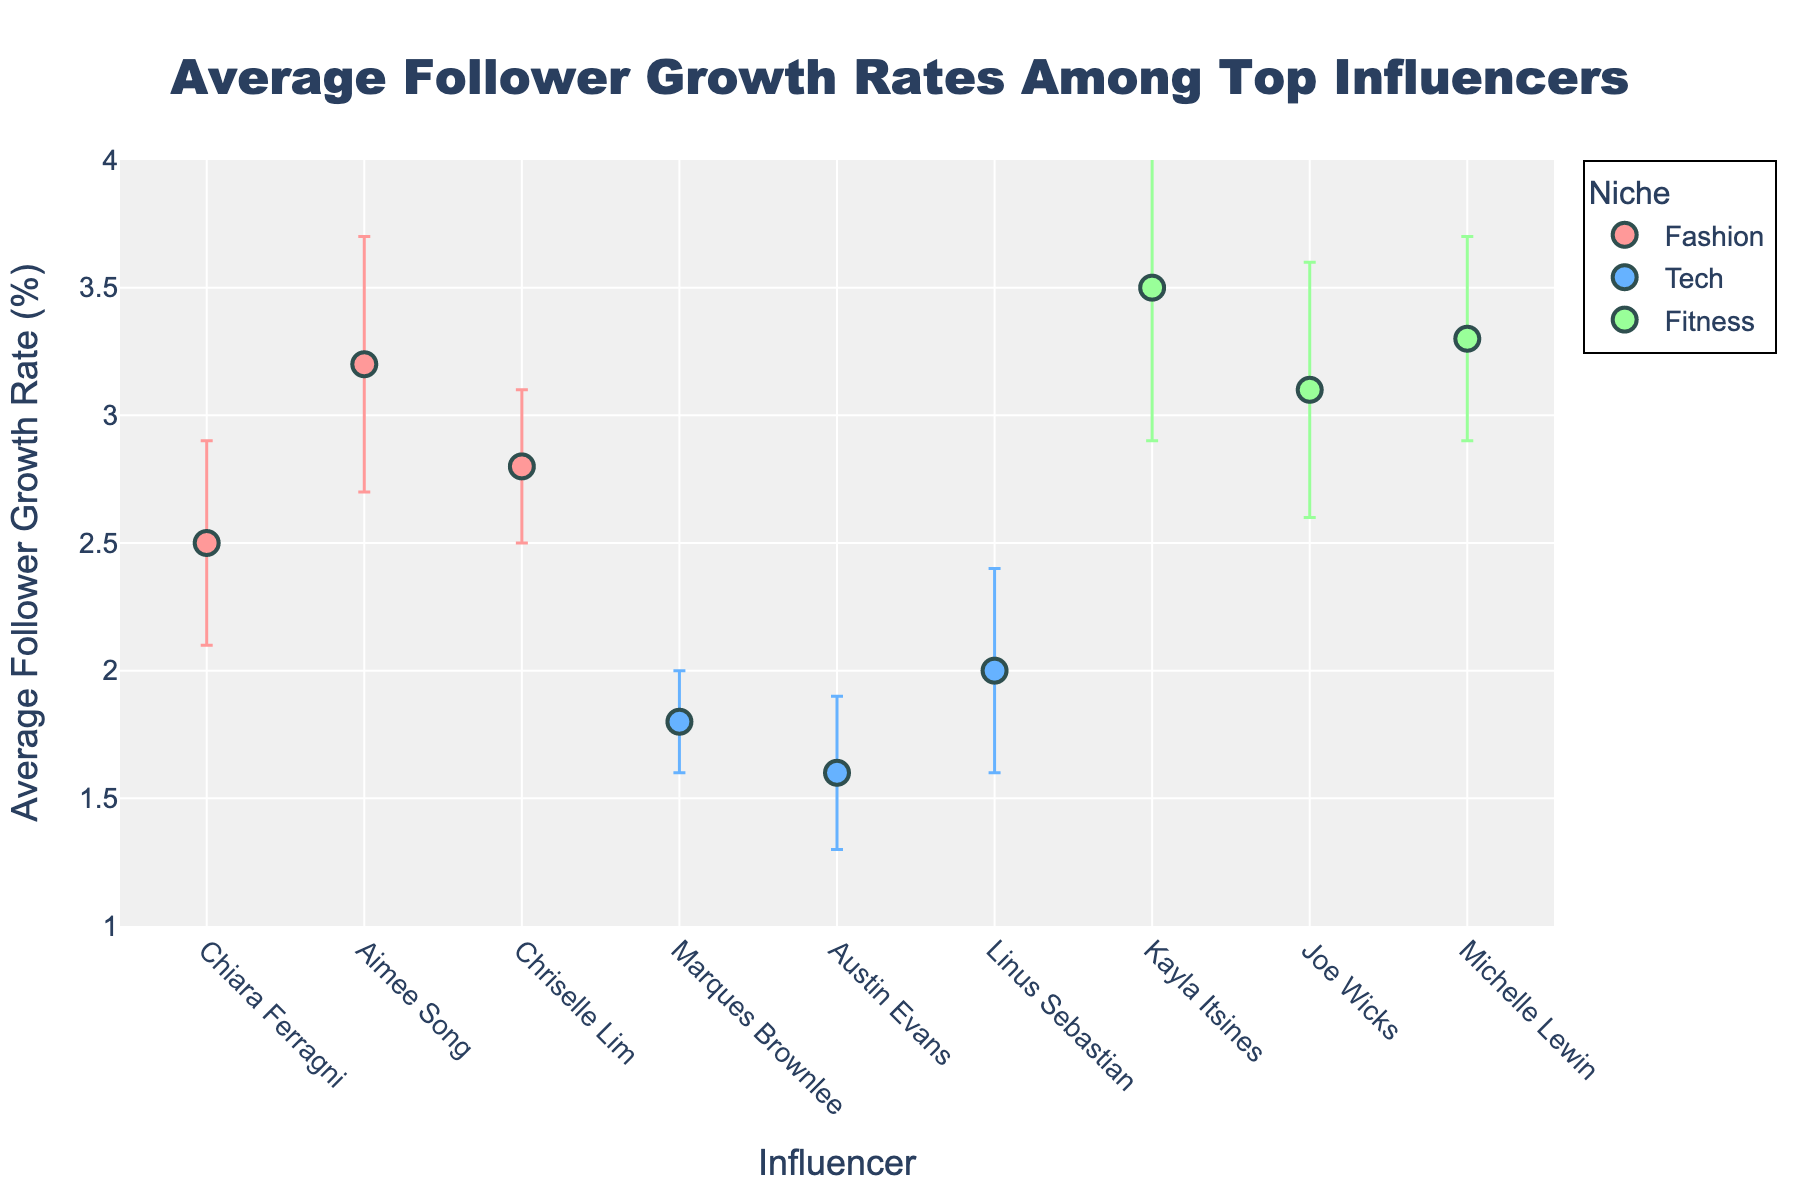What's the title of the plot? The title is typically located at the top of the plot. In this figure, it is "Average Follower Growth Rates Among Top Influencers".
Answer: Average Follower Growth Rates Among Top Influencers What is the y-axis measurement? The y-axis title is "Average Follower Growth Rate (%)", indicating that it measures the average follower growth rate in percentage.
Answer: Average Follower Growth Rate (%) How many influencers are represented in the fashion niche? By inspecting the x-axis labels under the 'Fashion' category and counting the data points (dots) within that niche, there are three influencers: Chiara Ferragni, Aimee Song, and Chriselle Lim.
Answer: 3 Which influencer in the tech niche has the highest average follower growth rate? By looking at the y-axis values of the dots representing tech influencers, Linus Sebastian has the highest at 2.0%.
Answer: Linus Sebastian Among the fitness influencers, who has the smallest error bar? By observing the size of the error bars for fitness influencers, Michelle Lewin's error bar is the smallest.
Answer: Michelle Lewin Which niche has the highest average follower growth rate? Comparing the highest y-axis values within each niche, the fitness niche shows the highest value of 3.5% (Kayla Itsines).
Answer: Fitness What's the average follower growth rate of the influencers in the fashion category? Sum the growth rates of Chiara Ferragni (2.5%), Aimee Song (3.2%), and Chriselle Lim (2.8%) and divide by the number of influencers: (2.5 + 3.2 + 2.8) / 3 = 2.83%.
Answer: 2.83% Which influencer has the largest standard deviation in their follower growth rate? By comparing the lengths of the error bars for each influencer, Kayla Itsines in the fitness niche has the largest standard deviation (0.6%).
Answer: Kayla Itsines Are there any influencers with equal average follower growth rates? If so, who? Observing the y-axis values, no two influencers share the exact same average follower growth rate.
Answer: No 